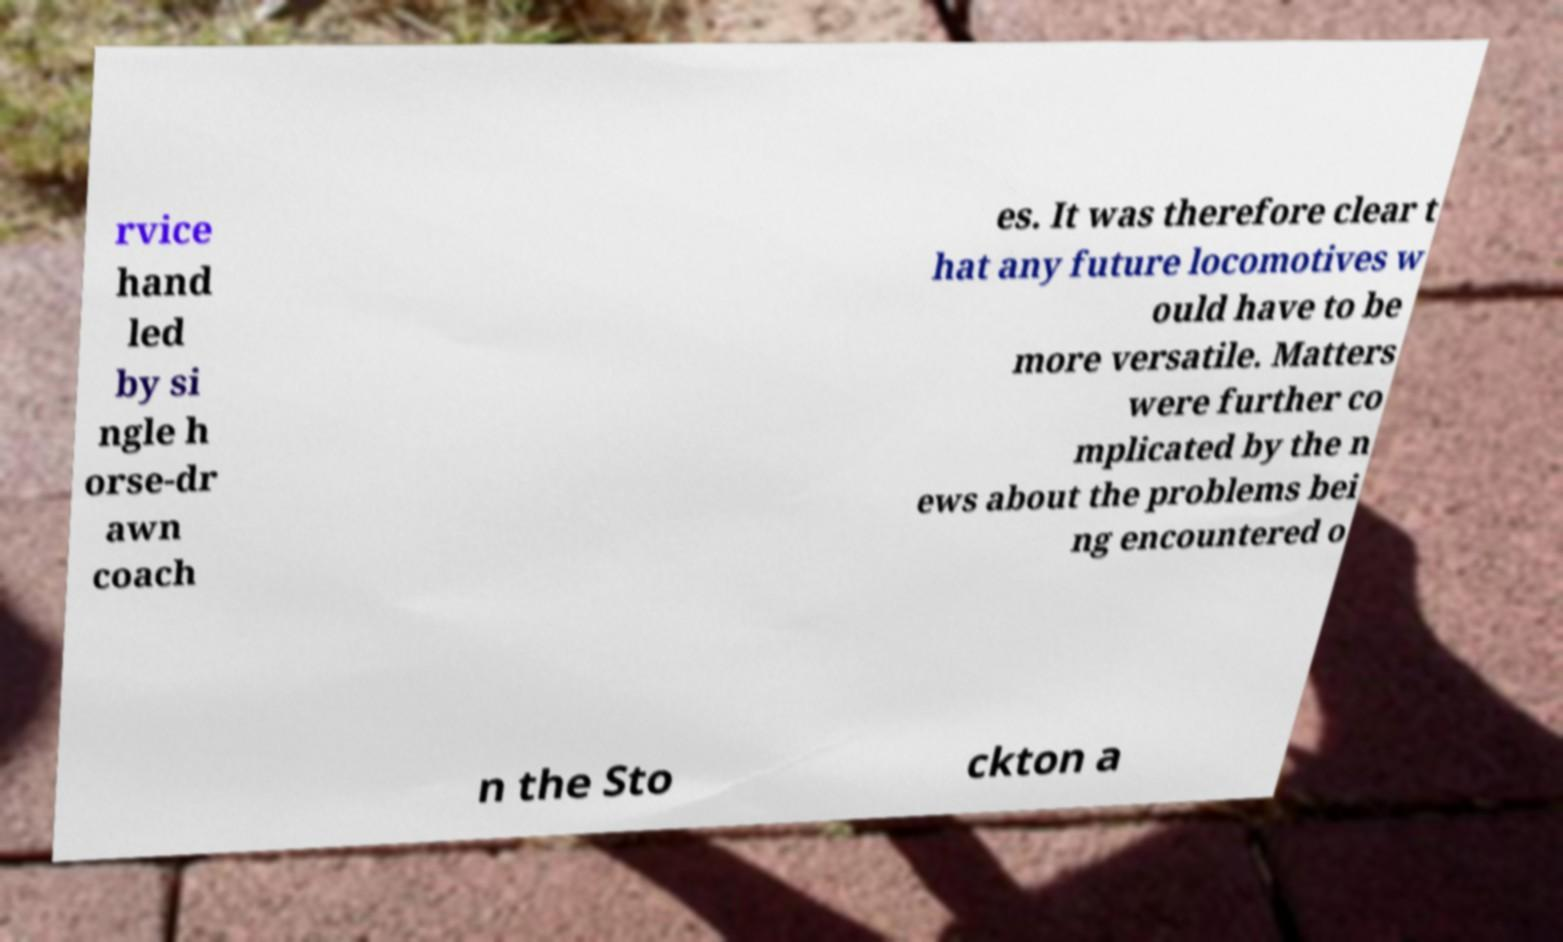Can you read and provide the text displayed in the image?This photo seems to have some interesting text. Can you extract and type it out for me? rvice hand led by si ngle h orse-dr awn coach es. It was therefore clear t hat any future locomotives w ould have to be more versatile. Matters were further co mplicated by the n ews about the problems bei ng encountered o n the Sto ckton a 